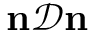<formula> <loc_0><loc_0><loc_500><loc_500>n \mathcal { D } n</formula> 